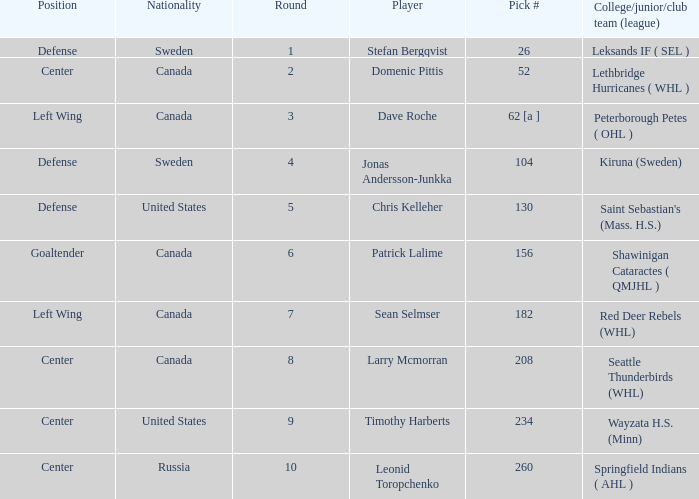Could you parse the entire table? {'header': ['Position', 'Nationality', 'Round', 'Player', 'Pick #', 'College/junior/club team (league)'], 'rows': [['Defense', 'Sweden', '1', 'Stefan Bergqvist', '26', 'Leksands IF ( SEL )'], ['Center', 'Canada', '2', 'Domenic Pittis', '52', 'Lethbridge Hurricanes ( WHL )'], ['Left Wing', 'Canada', '3', 'Dave Roche', '62 [a ]', 'Peterborough Petes ( OHL )'], ['Defense', 'Sweden', '4', 'Jonas Andersson-Junkka', '104', 'Kiruna (Sweden)'], ['Defense', 'United States', '5', 'Chris Kelleher', '130', "Saint Sebastian's (Mass. H.S.)"], ['Goaltender', 'Canada', '6', 'Patrick Lalime', '156', 'Shawinigan Cataractes ( QMJHL )'], ['Left Wing', 'Canada', '7', 'Sean Selmser', '182', 'Red Deer Rebels (WHL)'], ['Center', 'Canada', '8', 'Larry Mcmorran', '208', 'Seattle Thunderbirds (WHL)'], ['Center', 'United States', '9', 'Timothy Harberts', '234', 'Wayzata H.S. (Minn)'], ['Center', 'Russia', '10', 'Leonid Toropchenko', '260', 'Springfield Indians ( AHL )']]} What is the college/junior/club team (league) of the player who was pick number 130? Saint Sebastian's (Mass. H.S.). 